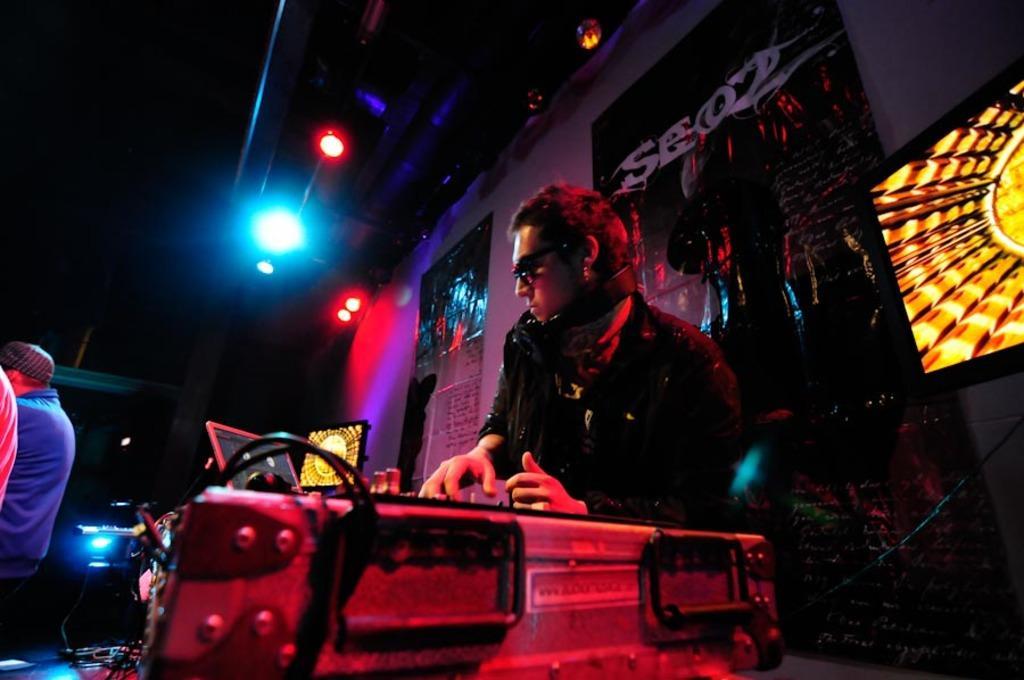How would you summarize this image in a sentence or two? People are present. There are lights on the top and there are posters on the wall. 